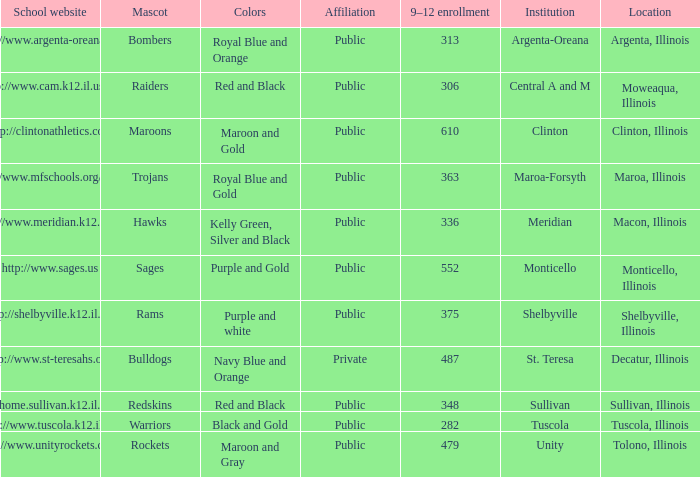What colors can you see players from Tolono, Illinois wearing? Maroon and Gray. 